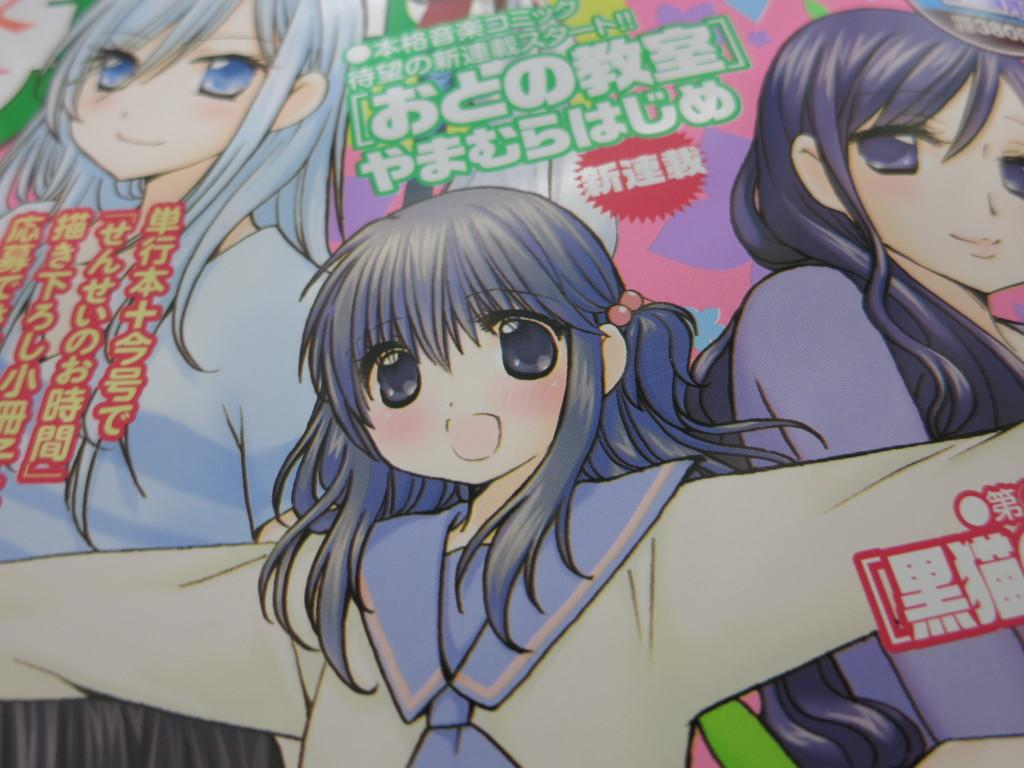What type of content is present in the image? The image contains a cartoon. What type of joke does the farmer tell in the image? There is no farmer or joke present in the image; it contains a cartoon. 